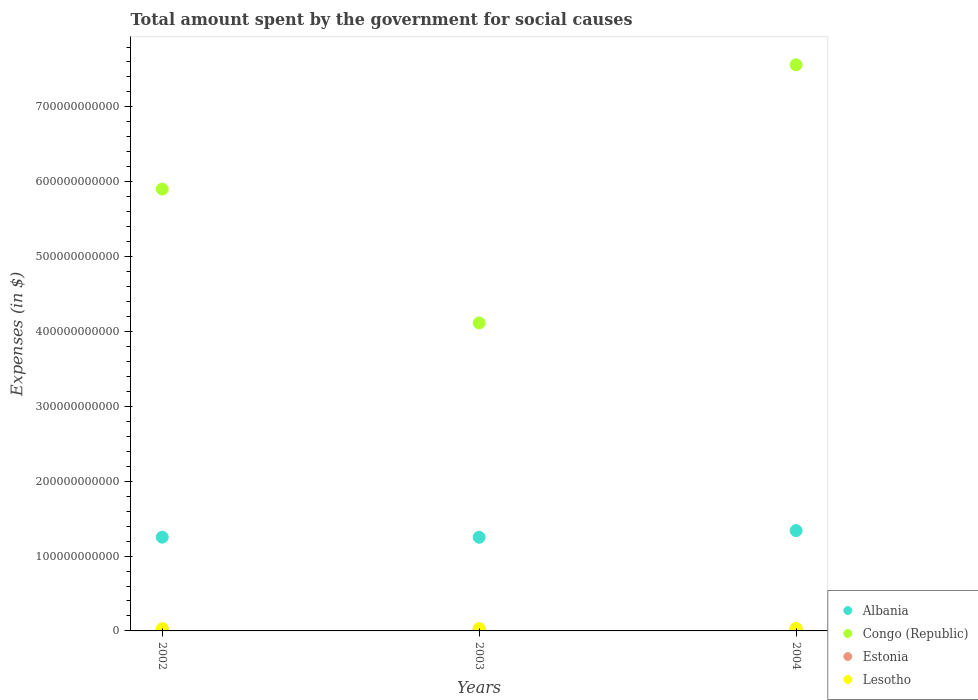Is the number of dotlines equal to the number of legend labels?
Your answer should be compact. Yes. What is the amount spent for social causes by the government in Lesotho in 2002?
Your answer should be compact. 2.98e+09. Across all years, what is the maximum amount spent for social causes by the government in Estonia?
Your answer should be very brief. 2.66e+09. Across all years, what is the minimum amount spent for social causes by the government in Albania?
Your response must be concise. 1.25e+11. In which year was the amount spent for social causes by the government in Estonia maximum?
Your answer should be very brief. 2004. What is the total amount spent for social causes by the government in Albania in the graph?
Make the answer very short. 3.84e+11. What is the difference between the amount spent for social causes by the government in Estonia in 2002 and that in 2004?
Keep it short and to the point. -5.12e+08. What is the difference between the amount spent for social causes by the government in Congo (Republic) in 2002 and the amount spent for social causes by the government in Albania in 2003?
Keep it short and to the point. 4.65e+11. What is the average amount spent for social causes by the government in Estonia per year?
Ensure brevity in your answer.  2.40e+09. In the year 2004, what is the difference between the amount spent for social causes by the government in Albania and amount spent for social causes by the government in Congo (Republic)?
Keep it short and to the point. -6.22e+11. What is the ratio of the amount spent for social causes by the government in Congo (Republic) in 2002 to that in 2004?
Your response must be concise. 0.78. Is the amount spent for social causes by the government in Albania in 2002 less than that in 2003?
Offer a terse response. No. What is the difference between the highest and the second highest amount spent for social causes by the government in Lesotho?
Provide a succinct answer. 2.97e+08. What is the difference between the highest and the lowest amount spent for social causes by the government in Albania?
Keep it short and to the point. 8.90e+09. Is it the case that in every year, the sum of the amount spent for social causes by the government in Albania and amount spent for social causes by the government in Estonia  is greater than the amount spent for social causes by the government in Congo (Republic)?
Offer a terse response. No. Is the amount spent for social causes by the government in Lesotho strictly less than the amount spent for social causes by the government in Albania over the years?
Keep it short and to the point. Yes. How many dotlines are there?
Ensure brevity in your answer.  4. How many years are there in the graph?
Offer a terse response. 3. What is the difference between two consecutive major ticks on the Y-axis?
Provide a succinct answer. 1.00e+11. Are the values on the major ticks of Y-axis written in scientific E-notation?
Ensure brevity in your answer.  No. Does the graph contain any zero values?
Your response must be concise. No. What is the title of the graph?
Make the answer very short. Total amount spent by the government for social causes. What is the label or title of the X-axis?
Offer a very short reply. Years. What is the label or title of the Y-axis?
Ensure brevity in your answer.  Expenses (in $). What is the Expenses (in $) of Albania in 2002?
Offer a very short reply. 1.25e+11. What is the Expenses (in $) in Congo (Republic) in 2002?
Your answer should be compact. 5.90e+11. What is the Expenses (in $) in Estonia in 2002?
Offer a terse response. 2.15e+09. What is the Expenses (in $) in Lesotho in 2002?
Make the answer very short. 2.98e+09. What is the Expenses (in $) in Albania in 2003?
Provide a succinct answer. 1.25e+11. What is the Expenses (in $) of Congo (Republic) in 2003?
Your response must be concise. 4.11e+11. What is the Expenses (in $) of Estonia in 2003?
Your response must be concise. 2.40e+09. What is the Expenses (in $) of Lesotho in 2003?
Provide a succinct answer. 3.04e+09. What is the Expenses (in $) of Albania in 2004?
Offer a terse response. 1.34e+11. What is the Expenses (in $) in Congo (Republic) in 2004?
Provide a succinct answer. 7.56e+11. What is the Expenses (in $) in Estonia in 2004?
Offer a very short reply. 2.66e+09. What is the Expenses (in $) of Lesotho in 2004?
Provide a short and direct response. 3.33e+09. Across all years, what is the maximum Expenses (in $) of Albania?
Ensure brevity in your answer.  1.34e+11. Across all years, what is the maximum Expenses (in $) of Congo (Republic)?
Offer a terse response. 7.56e+11. Across all years, what is the maximum Expenses (in $) of Estonia?
Your answer should be compact. 2.66e+09. Across all years, what is the maximum Expenses (in $) in Lesotho?
Provide a short and direct response. 3.33e+09. Across all years, what is the minimum Expenses (in $) in Albania?
Keep it short and to the point. 1.25e+11. Across all years, what is the minimum Expenses (in $) of Congo (Republic)?
Offer a very short reply. 4.11e+11. Across all years, what is the minimum Expenses (in $) in Estonia?
Offer a terse response. 2.15e+09. Across all years, what is the minimum Expenses (in $) in Lesotho?
Your response must be concise. 2.98e+09. What is the total Expenses (in $) of Albania in the graph?
Offer a terse response. 3.84e+11. What is the total Expenses (in $) of Congo (Republic) in the graph?
Offer a terse response. 1.76e+12. What is the total Expenses (in $) in Estonia in the graph?
Provide a short and direct response. 7.20e+09. What is the total Expenses (in $) in Lesotho in the graph?
Keep it short and to the point. 9.35e+09. What is the difference between the Expenses (in $) in Albania in 2002 and that in 2003?
Provide a short and direct response. 1.00e+08. What is the difference between the Expenses (in $) in Congo (Republic) in 2002 and that in 2003?
Your answer should be compact. 1.79e+11. What is the difference between the Expenses (in $) in Estonia in 2002 and that in 2003?
Make the answer very short. -2.54e+08. What is the difference between the Expenses (in $) of Lesotho in 2002 and that in 2003?
Make the answer very short. -5.50e+07. What is the difference between the Expenses (in $) of Albania in 2002 and that in 2004?
Make the answer very short. -8.80e+09. What is the difference between the Expenses (in $) of Congo (Republic) in 2002 and that in 2004?
Offer a very short reply. -1.66e+11. What is the difference between the Expenses (in $) of Estonia in 2002 and that in 2004?
Make the answer very short. -5.12e+08. What is the difference between the Expenses (in $) of Lesotho in 2002 and that in 2004?
Offer a very short reply. -3.52e+08. What is the difference between the Expenses (in $) of Albania in 2003 and that in 2004?
Your response must be concise. -8.90e+09. What is the difference between the Expenses (in $) in Congo (Republic) in 2003 and that in 2004?
Give a very brief answer. -3.45e+11. What is the difference between the Expenses (in $) of Estonia in 2003 and that in 2004?
Give a very brief answer. -2.58e+08. What is the difference between the Expenses (in $) in Lesotho in 2003 and that in 2004?
Keep it short and to the point. -2.97e+08. What is the difference between the Expenses (in $) of Albania in 2002 and the Expenses (in $) of Congo (Republic) in 2003?
Make the answer very short. -2.86e+11. What is the difference between the Expenses (in $) in Albania in 2002 and the Expenses (in $) in Estonia in 2003?
Offer a terse response. 1.23e+11. What is the difference between the Expenses (in $) of Albania in 2002 and the Expenses (in $) of Lesotho in 2003?
Make the answer very short. 1.22e+11. What is the difference between the Expenses (in $) in Congo (Republic) in 2002 and the Expenses (in $) in Estonia in 2003?
Offer a terse response. 5.88e+11. What is the difference between the Expenses (in $) of Congo (Republic) in 2002 and the Expenses (in $) of Lesotho in 2003?
Give a very brief answer. 5.87e+11. What is the difference between the Expenses (in $) in Estonia in 2002 and the Expenses (in $) in Lesotho in 2003?
Your answer should be very brief. -8.91e+08. What is the difference between the Expenses (in $) in Albania in 2002 and the Expenses (in $) in Congo (Republic) in 2004?
Your response must be concise. -6.31e+11. What is the difference between the Expenses (in $) of Albania in 2002 and the Expenses (in $) of Estonia in 2004?
Offer a terse response. 1.23e+11. What is the difference between the Expenses (in $) of Albania in 2002 and the Expenses (in $) of Lesotho in 2004?
Your response must be concise. 1.22e+11. What is the difference between the Expenses (in $) of Congo (Republic) in 2002 and the Expenses (in $) of Estonia in 2004?
Your answer should be very brief. 5.88e+11. What is the difference between the Expenses (in $) of Congo (Republic) in 2002 and the Expenses (in $) of Lesotho in 2004?
Provide a succinct answer. 5.87e+11. What is the difference between the Expenses (in $) of Estonia in 2002 and the Expenses (in $) of Lesotho in 2004?
Make the answer very short. -1.19e+09. What is the difference between the Expenses (in $) in Albania in 2003 and the Expenses (in $) in Congo (Republic) in 2004?
Provide a succinct answer. -6.31e+11. What is the difference between the Expenses (in $) of Albania in 2003 and the Expenses (in $) of Estonia in 2004?
Your answer should be very brief. 1.22e+11. What is the difference between the Expenses (in $) of Albania in 2003 and the Expenses (in $) of Lesotho in 2004?
Offer a very short reply. 1.22e+11. What is the difference between the Expenses (in $) in Congo (Republic) in 2003 and the Expenses (in $) in Estonia in 2004?
Your answer should be compact. 4.09e+11. What is the difference between the Expenses (in $) in Congo (Republic) in 2003 and the Expenses (in $) in Lesotho in 2004?
Provide a succinct answer. 4.08e+11. What is the difference between the Expenses (in $) of Estonia in 2003 and the Expenses (in $) of Lesotho in 2004?
Give a very brief answer. -9.34e+08. What is the average Expenses (in $) of Albania per year?
Offer a very short reply. 1.28e+11. What is the average Expenses (in $) in Congo (Republic) per year?
Your answer should be very brief. 5.86e+11. What is the average Expenses (in $) in Estonia per year?
Make the answer very short. 2.40e+09. What is the average Expenses (in $) of Lesotho per year?
Ensure brevity in your answer.  3.12e+09. In the year 2002, what is the difference between the Expenses (in $) of Albania and Expenses (in $) of Congo (Republic)?
Provide a short and direct response. -4.65e+11. In the year 2002, what is the difference between the Expenses (in $) of Albania and Expenses (in $) of Estonia?
Ensure brevity in your answer.  1.23e+11. In the year 2002, what is the difference between the Expenses (in $) in Albania and Expenses (in $) in Lesotho?
Offer a terse response. 1.22e+11. In the year 2002, what is the difference between the Expenses (in $) of Congo (Republic) and Expenses (in $) of Estonia?
Offer a very short reply. 5.88e+11. In the year 2002, what is the difference between the Expenses (in $) of Congo (Republic) and Expenses (in $) of Lesotho?
Provide a succinct answer. 5.87e+11. In the year 2002, what is the difference between the Expenses (in $) of Estonia and Expenses (in $) of Lesotho?
Ensure brevity in your answer.  -8.36e+08. In the year 2003, what is the difference between the Expenses (in $) in Albania and Expenses (in $) in Congo (Republic)?
Your answer should be very brief. -2.86e+11. In the year 2003, what is the difference between the Expenses (in $) in Albania and Expenses (in $) in Estonia?
Your answer should be very brief. 1.23e+11. In the year 2003, what is the difference between the Expenses (in $) in Albania and Expenses (in $) in Lesotho?
Ensure brevity in your answer.  1.22e+11. In the year 2003, what is the difference between the Expenses (in $) in Congo (Republic) and Expenses (in $) in Estonia?
Make the answer very short. 4.09e+11. In the year 2003, what is the difference between the Expenses (in $) in Congo (Republic) and Expenses (in $) in Lesotho?
Keep it short and to the point. 4.08e+11. In the year 2003, what is the difference between the Expenses (in $) of Estonia and Expenses (in $) of Lesotho?
Offer a very short reply. -6.37e+08. In the year 2004, what is the difference between the Expenses (in $) of Albania and Expenses (in $) of Congo (Republic)?
Offer a terse response. -6.22e+11. In the year 2004, what is the difference between the Expenses (in $) in Albania and Expenses (in $) in Estonia?
Give a very brief answer. 1.31e+11. In the year 2004, what is the difference between the Expenses (in $) of Albania and Expenses (in $) of Lesotho?
Provide a succinct answer. 1.31e+11. In the year 2004, what is the difference between the Expenses (in $) in Congo (Republic) and Expenses (in $) in Estonia?
Your answer should be compact. 7.54e+11. In the year 2004, what is the difference between the Expenses (in $) in Congo (Republic) and Expenses (in $) in Lesotho?
Offer a very short reply. 7.53e+11. In the year 2004, what is the difference between the Expenses (in $) of Estonia and Expenses (in $) of Lesotho?
Your answer should be very brief. -6.76e+08. What is the ratio of the Expenses (in $) in Albania in 2002 to that in 2003?
Offer a terse response. 1. What is the ratio of the Expenses (in $) of Congo (Republic) in 2002 to that in 2003?
Your response must be concise. 1.43. What is the ratio of the Expenses (in $) of Estonia in 2002 to that in 2003?
Your response must be concise. 0.89. What is the ratio of the Expenses (in $) in Lesotho in 2002 to that in 2003?
Ensure brevity in your answer.  0.98. What is the ratio of the Expenses (in $) in Albania in 2002 to that in 2004?
Your response must be concise. 0.93. What is the ratio of the Expenses (in $) in Congo (Republic) in 2002 to that in 2004?
Give a very brief answer. 0.78. What is the ratio of the Expenses (in $) in Estonia in 2002 to that in 2004?
Offer a terse response. 0.81. What is the ratio of the Expenses (in $) of Lesotho in 2002 to that in 2004?
Your response must be concise. 0.89. What is the ratio of the Expenses (in $) of Albania in 2003 to that in 2004?
Your answer should be compact. 0.93. What is the ratio of the Expenses (in $) in Congo (Republic) in 2003 to that in 2004?
Keep it short and to the point. 0.54. What is the ratio of the Expenses (in $) of Estonia in 2003 to that in 2004?
Provide a short and direct response. 0.9. What is the ratio of the Expenses (in $) of Lesotho in 2003 to that in 2004?
Give a very brief answer. 0.91. What is the difference between the highest and the second highest Expenses (in $) in Albania?
Your answer should be very brief. 8.80e+09. What is the difference between the highest and the second highest Expenses (in $) in Congo (Republic)?
Your answer should be very brief. 1.66e+11. What is the difference between the highest and the second highest Expenses (in $) in Estonia?
Your response must be concise. 2.58e+08. What is the difference between the highest and the second highest Expenses (in $) of Lesotho?
Your answer should be compact. 2.97e+08. What is the difference between the highest and the lowest Expenses (in $) of Albania?
Make the answer very short. 8.90e+09. What is the difference between the highest and the lowest Expenses (in $) in Congo (Republic)?
Your response must be concise. 3.45e+11. What is the difference between the highest and the lowest Expenses (in $) of Estonia?
Make the answer very short. 5.12e+08. What is the difference between the highest and the lowest Expenses (in $) of Lesotho?
Offer a terse response. 3.52e+08. 